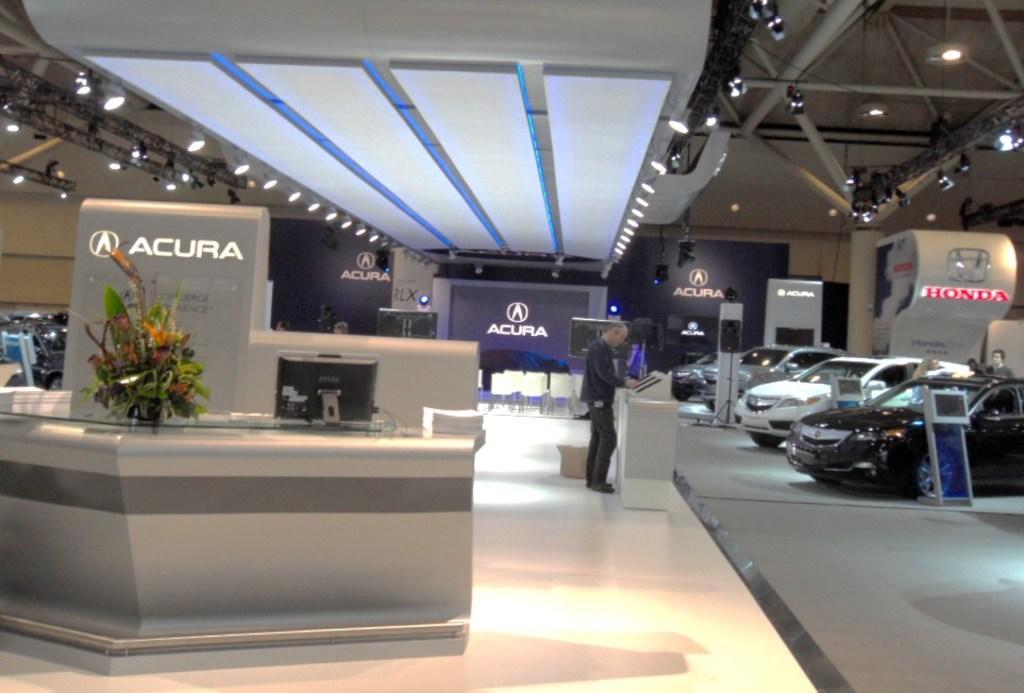Could you give a brief overview of what you see in this image? In the middle of the image there are some tables, on the tables there are some screens and plants and a man is standing. Behind him there are some chairs. On the right side of the image there are some vehicles. Behind the vehicles a man is standing. At the top of the image there is roof and lights. 